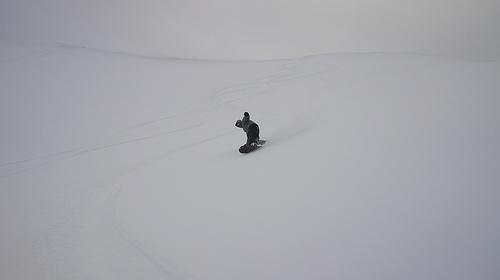How many people are in the photo?
Give a very brief answer. 1. 